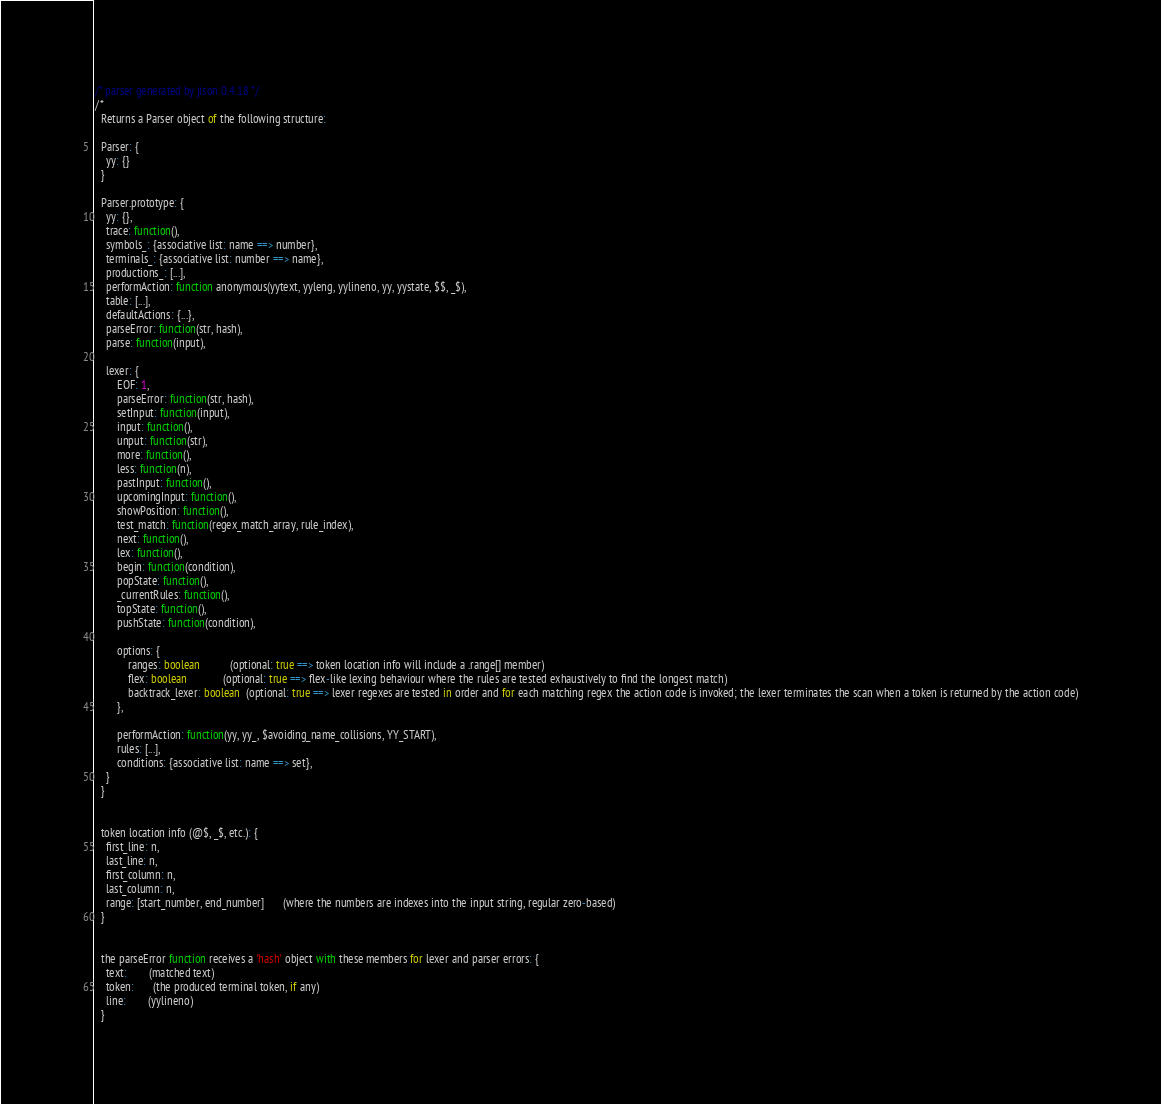Convert code to text. <code><loc_0><loc_0><loc_500><loc_500><_JavaScript_>/* parser generated by jison 0.4.18 */
/*
  Returns a Parser object of the following structure:

  Parser: {
    yy: {}
  }

  Parser.prototype: {
    yy: {},
    trace: function(),
    symbols_: {associative list: name ==> number},
    terminals_: {associative list: number ==> name},
    productions_: [...],
    performAction: function anonymous(yytext, yyleng, yylineno, yy, yystate, $$, _$),
    table: [...],
    defaultActions: {...},
    parseError: function(str, hash),
    parse: function(input),

    lexer: {
        EOF: 1,
        parseError: function(str, hash),
        setInput: function(input),
        input: function(),
        unput: function(str),
        more: function(),
        less: function(n),
        pastInput: function(),
        upcomingInput: function(),
        showPosition: function(),
        test_match: function(regex_match_array, rule_index),
        next: function(),
        lex: function(),
        begin: function(condition),
        popState: function(),
        _currentRules: function(),
        topState: function(),
        pushState: function(condition),

        options: {
            ranges: boolean           (optional: true ==> token location info will include a .range[] member)
            flex: boolean             (optional: true ==> flex-like lexing behaviour where the rules are tested exhaustively to find the longest match)
            backtrack_lexer: boolean  (optional: true ==> lexer regexes are tested in order and for each matching regex the action code is invoked; the lexer terminates the scan when a token is returned by the action code)
        },

        performAction: function(yy, yy_, $avoiding_name_collisions, YY_START),
        rules: [...],
        conditions: {associative list: name ==> set},
    }
  }


  token location info (@$, _$, etc.): {
    first_line: n,
    last_line: n,
    first_column: n,
    last_column: n,
    range: [start_number, end_number]       (where the numbers are indexes into the input string, regular zero-based)
  }


  the parseError function receives a 'hash' object with these members for lexer and parser errors: {
    text:        (matched text)
    token:       (the produced terminal token, if any)
    line:        (yylineno)
  }</code> 